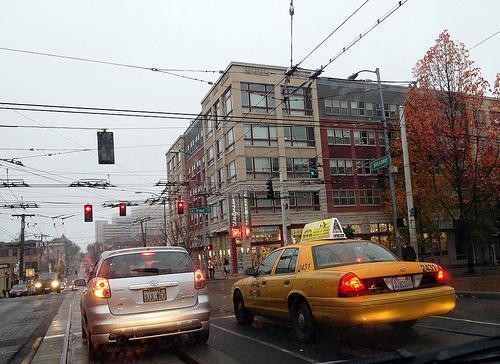How many minivans?
Give a very brief answer. 1. 